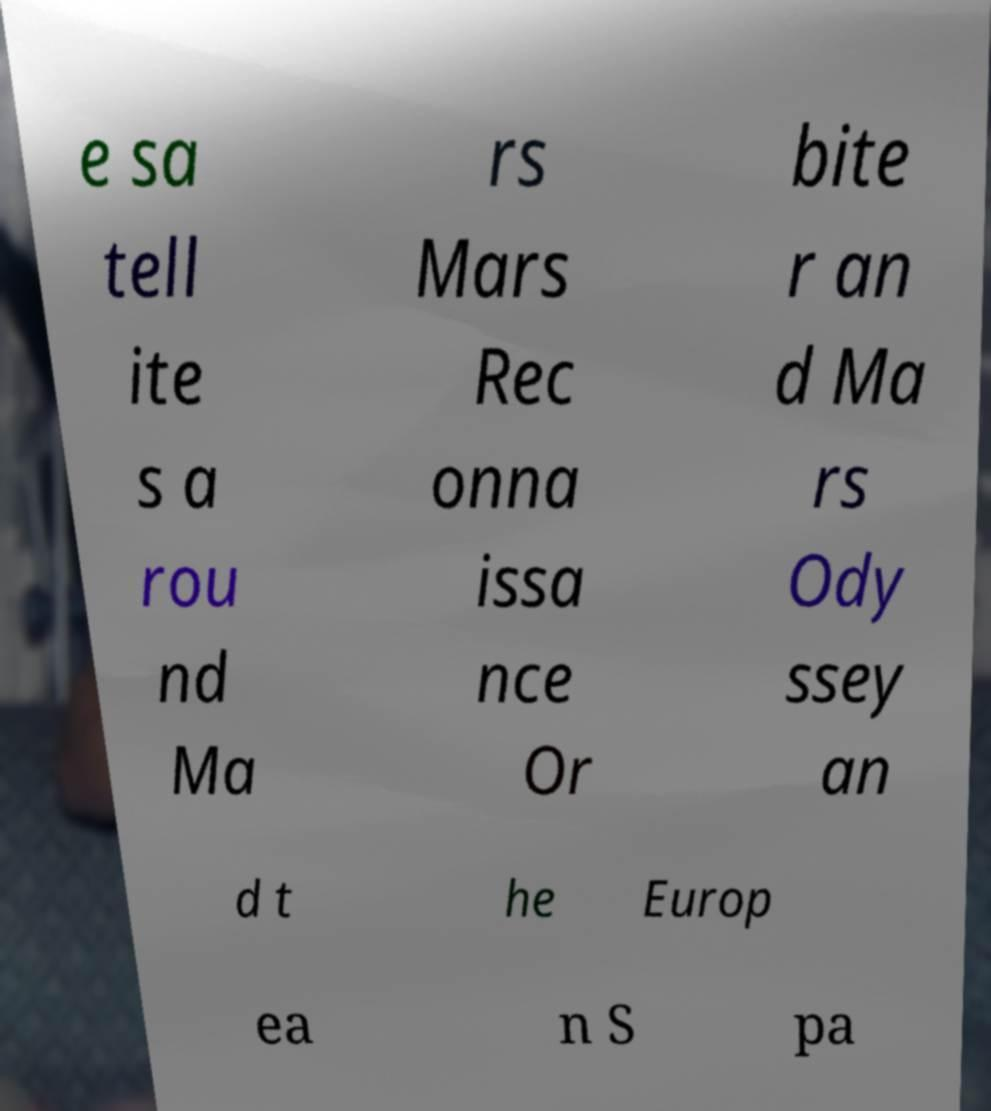For documentation purposes, I need the text within this image transcribed. Could you provide that? e sa tell ite s a rou nd Ma rs Mars Rec onna issa nce Or bite r an d Ma rs Ody ssey an d t he Europ ea n S pa 